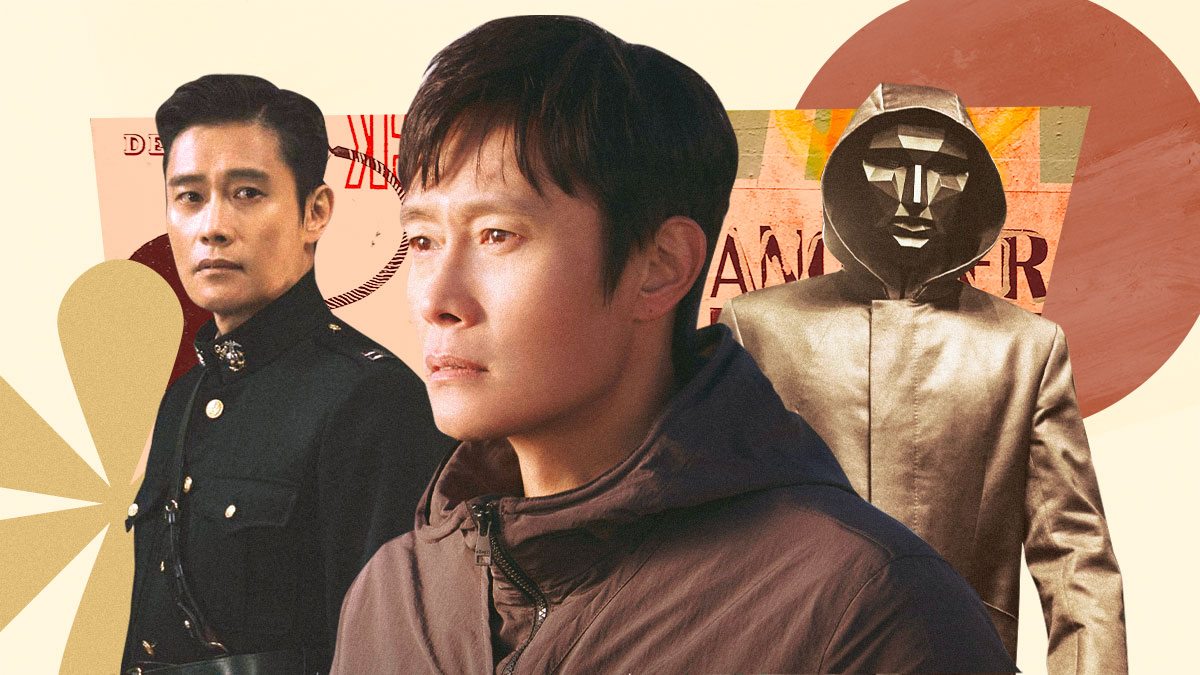Can you discuss the symbolism behind the costumes worn by the actor? Certainly, the varying costumes signify the versatile characters the actor embodies. The military uniform symbolizes discipline and authority, the pedestrian clothes represent the everyday human experience, and the hooded figure indicates a mysterious, possibly otherworldly character. Each costume marks a distinct narrative voice, contributing to a broader thematic exploration within his roles. 